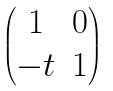Convert formula to latex. <formula><loc_0><loc_0><loc_500><loc_500>\begin{pmatrix} 1 & 0 \\ - t & 1 \end{pmatrix}</formula> 